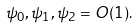<formula> <loc_0><loc_0><loc_500><loc_500>\psi _ { 0 } , \psi _ { 1 } , \psi _ { 2 } = O ( 1 ) .</formula> 